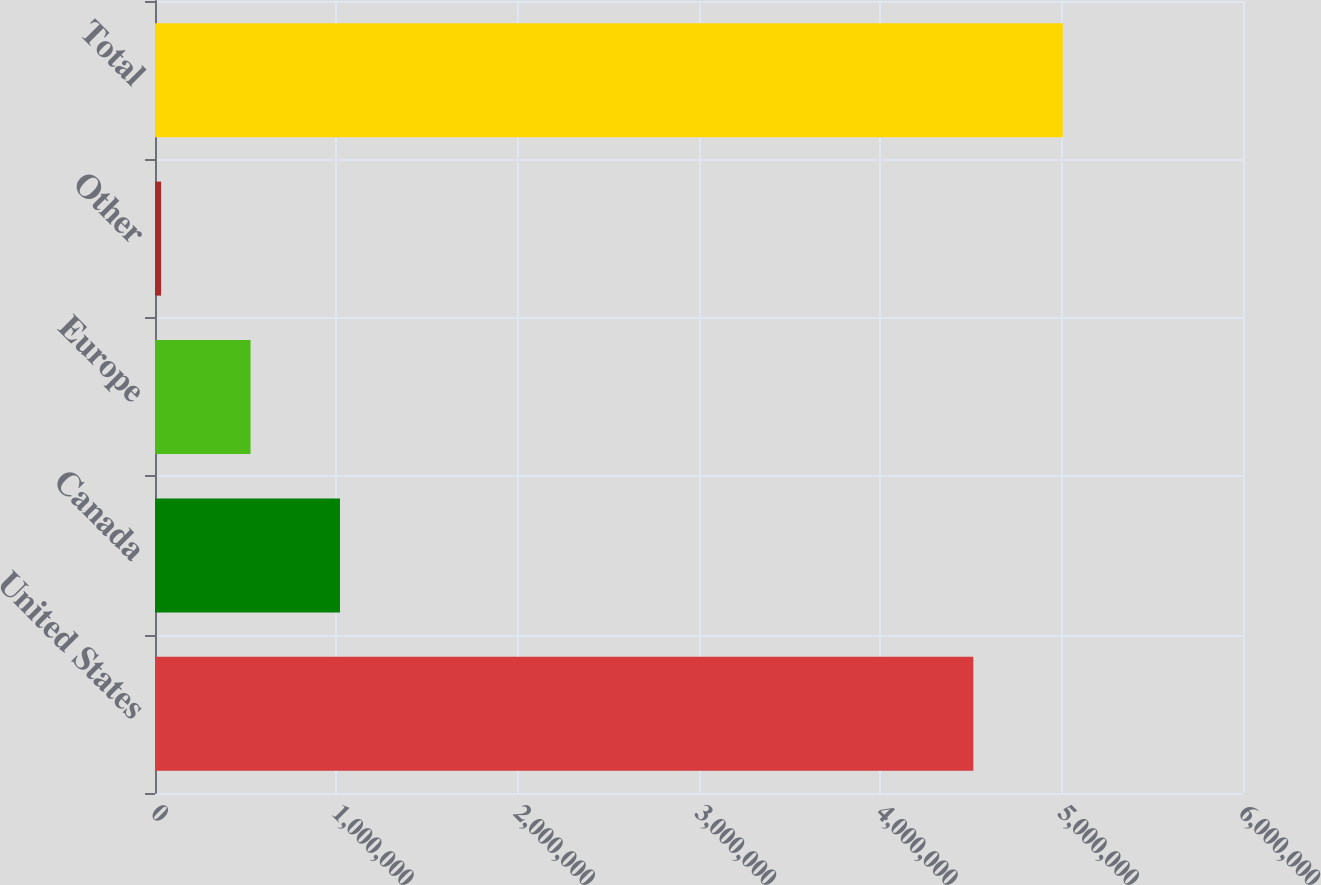Convert chart to OTSL. <chart><loc_0><loc_0><loc_500><loc_500><bar_chart><fcel>United States<fcel>Canada<fcel>Europe<fcel>Other<fcel>Total<nl><fcel>4.51281e+06<fcel>1.02009e+06<fcel>526920<fcel>33749<fcel>5.00598e+06<nl></chart> 